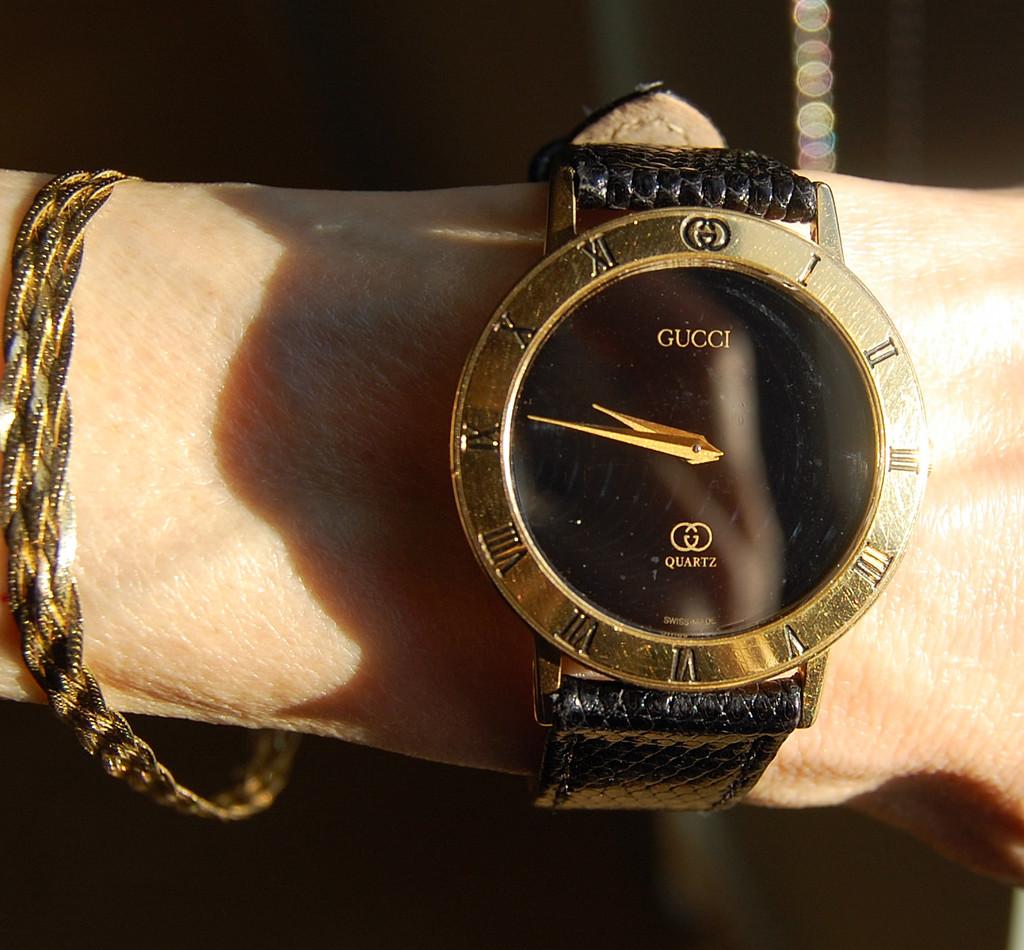Is this watch made from quartz?
Provide a succinct answer. Yes. 